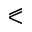<formula> <loc_0><loc_0><loc_500><loc_500>\ e q s l a n t l e s s</formula> 